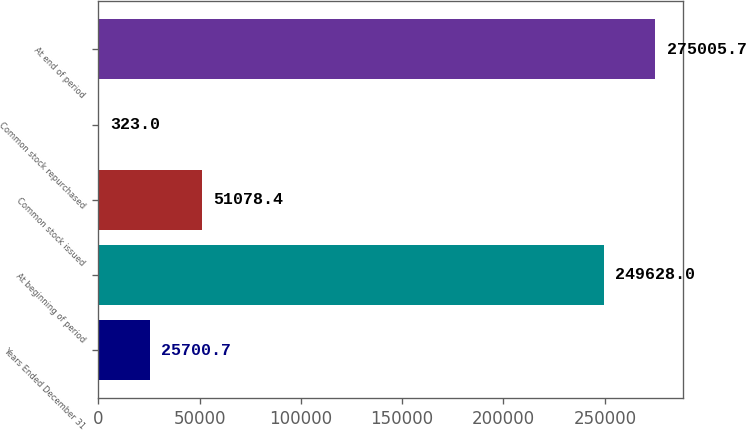<chart> <loc_0><loc_0><loc_500><loc_500><bar_chart><fcel>Years Ended December 31<fcel>At beginning of period<fcel>Common stock issued<fcel>Common stock repurchased<fcel>At end of period<nl><fcel>25700.7<fcel>249628<fcel>51078.4<fcel>323<fcel>275006<nl></chart> 